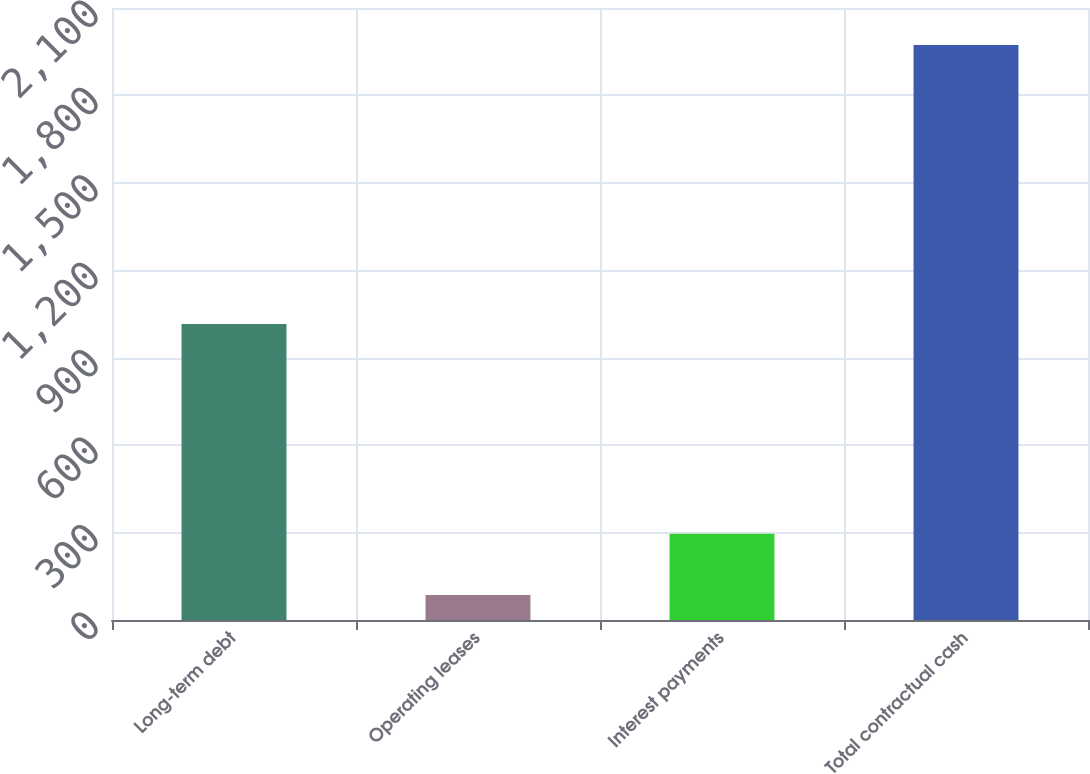<chart> <loc_0><loc_0><loc_500><loc_500><bar_chart><fcel>Long-term debt<fcel>Operating leases<fcel>Interest payments<fcel>Total contractual cash<nl><fcel>1015.8<fcel>86.2<fcel>295.9<fcel>1972.9<nl></chart> 